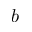<formula> <loc_0><loc_0><loc_500><loc_500>b</formula> 